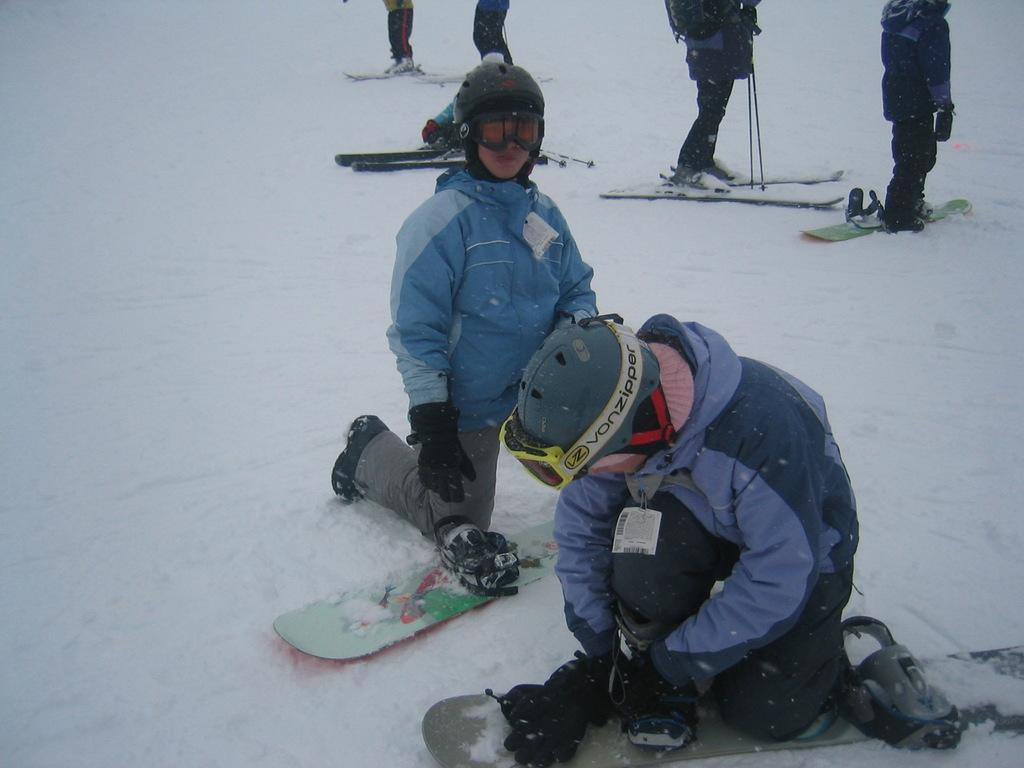How many people are in the image? There are persons in the image, but the exact number cannot be determined from the provided facts. What are the persons in the image doing? The presence of ski boards suggests that the persons might be skiing. What type of terrain is visible in the image? There is snow in the image, indicating a winter or snowy environment. Reasoning: Let' Let's think step by step in order to produce the conversation. We start by acknowledging the presence of persons in the image, but we cannot determine the exact number from the provided facts. Next, we observe the ski boards, which suggest that the persons might be skiing. Finally, we describe the environment by mentioning the presence of snow, which indicates a winter or snowy setting. Absurd Question/Answer: Can you see a stream of water flowing through the snow in the image? There is no mention of a stream of water in the provided facts, so we cannot determine if one is present in the image. What type of match is being played in the image? There is no mention of a match or any competitive activity in the provided facts, so we cannot determine if one is taking place in the image. Can you see a stream of water flowing through the snow in the image? There is no mention of a stream of water in the provided facts, so we cannot determine if one is present in the image. What type of match is being played in the image? There is no mention of a match or any competitive activity in the provided facts, so we cannot determine if one is taking place in the image. 